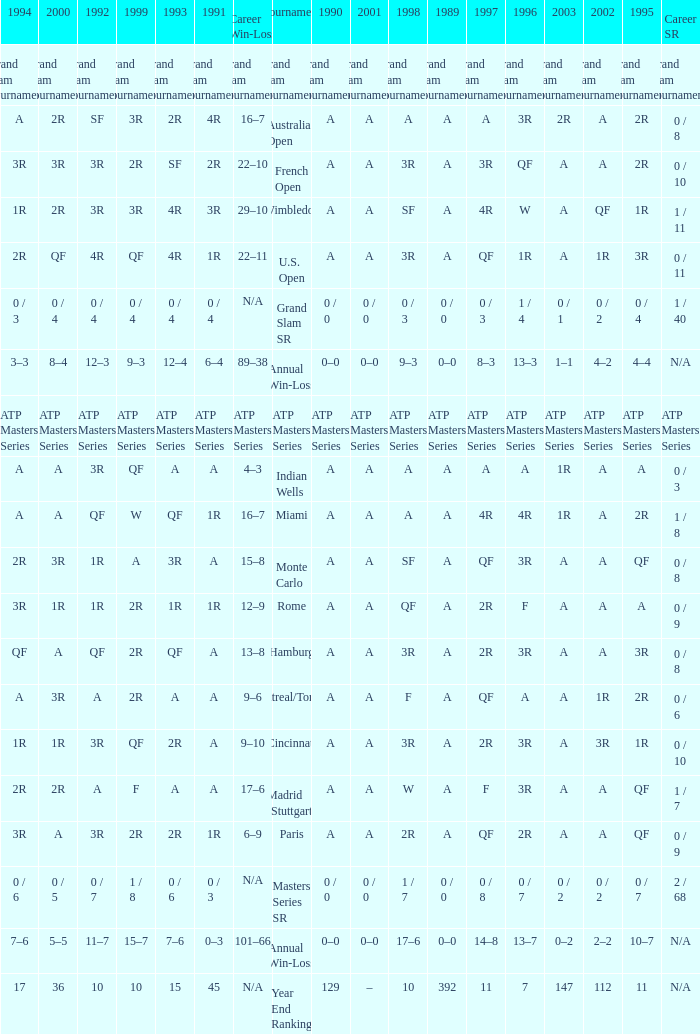What was the value in 1989 with QF in 1997 and A in 1993? A. 